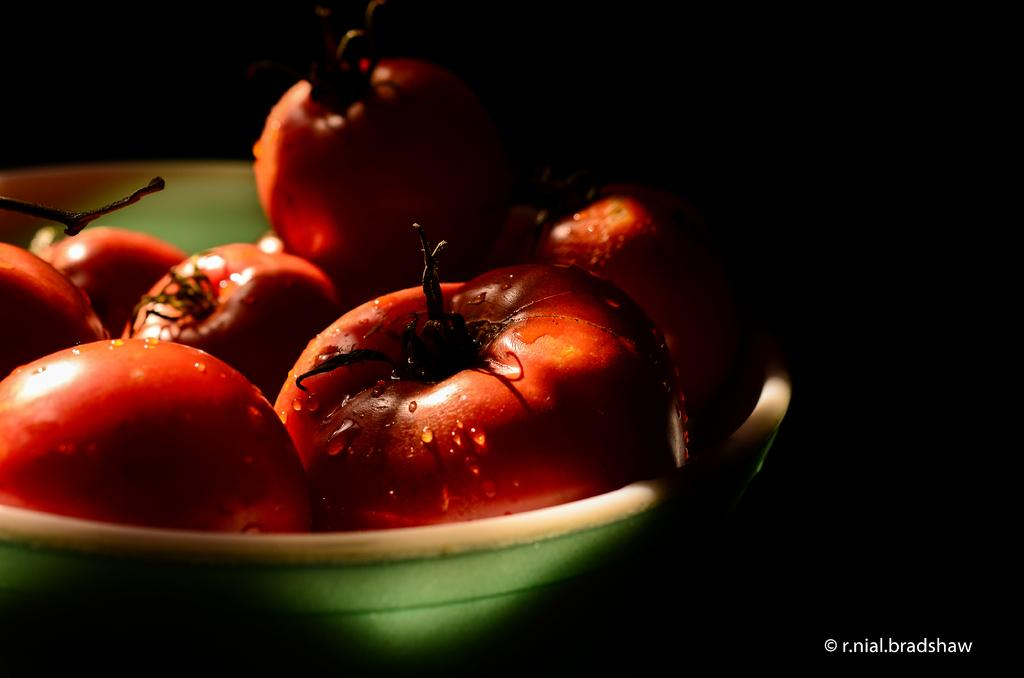What type of food is in the bowl in the image? There are tomatoes in a bowl in the image. How would you describe the lighting in the image? The background of the image is dark. Is there any additional information or branding on the image? Yes, there is a watermark on the image. Are there any hands holding the tomatoes in the image? No, there are no hands visible in the image. 